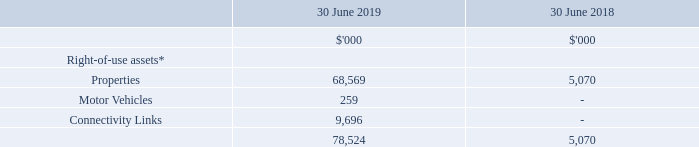12 Leases
(a) Leases
(i) Amounts recognised in the Consolidated Balance Sheet
The Consolidated Balance Sheet includes the following amounts relating to leases:
Additions to the right-of-use assets during the 2019 financial year were $0.3 million.
(ii) Amounts recognised in the Consolidated Statement of Comprehensive Income
The Consolidated Statement of Comprehensive Income shows the following amounts relating to leases:
The total cash outflow for leases in 2019 was $8.6 million.
(iii) The group’s leasing activities and how these are accounted for
The Group has a number of leases over property, motor vehicles, and connectivity links that have varying terms, escalation clauses and renewal rights.
Leases are recognised as a right-of-use asset and a corresponding liability at the date at which the leased asset is available for use by the Group. Each lease payment is allocated between the liability and finance cost. The finance cost is charged to profit or loss over the lease term so as to produce a constant periodic rate of interest on the remaining balance of the liability for each year. The right-of-use asset is depreciated over the shorter of the asset's useful life and the lease term on a straight-line basis.
Assets and liabilities arising from a lease are initially measured on a present value basis. Lease liabilities include the net present value of the following lease payments:
- fixed payments (including in-substance fixed payments), less any lease incentives receivable  fixed payments (including in-substance fixed payments), less any lease incentives receivable
- variable lease payments that are based on an index or a rate
- amounts expected to be payable by the lessee under residual value guarantees
- the exercise price of a purchase option if the lessee is reasonably certain to exercise that option, and
- payments of penalties for terminating the lease, if the lease term reflects the lessee exercising that option.
The lease payments are discounted using the interest rate implicit in the lease, if that rate can be determined, or the Group’s incremental borrowing rate.
Right-of-use assets are measured at cost comprising the following:
- the amount of the initial measurement of lease liability
- any lease payments made at or before the commencement date, less any lease incentives received
- any initial direct costs, and
- restoration costs.
Payments associated with short-term leases and leases of low-value assets are recognised on a straight-line basis as an expense in profit or loss. Short-term leases are leases with a lease term of 12 months or less. Low-value assets comprise IT-equipment and small items of office furniture.
(iv) Extension and termination options
Extension and termination options are included in a number of property and equipment leases across the Group. These terms are used to maximise operational flexibility in terms of managing contracts. The majority of extension and termination options held are exercisable only by the Group and not by the respective lessor.
What costs are taken into account for measuring Right-of-use assets? The amount of the initial measurement of lease liability, any lease payments made at or before the commencement date, less any lease incentives received, any initial direct costs, restoration costs. How much was the additions to the right-of-use assets during FY19? $0.3 million. How much value of right-of-use assets in relation to leases are recognised by the Group?
Answer scale should be: thousand. 78,524. Which year has the higher total right-of-use assets? 78,524> 5,070
Answer: 2019. What was the percentage change in values of properties between 2018 and 2019?
Answer scale should be: percent. (68,569 - 5,070) / 5,070 
Answer: 1252.45. What was the sum of values of motor vehicles and connectivity links in 2019?
Answer scale should be: thousand. 259 + 9,696 
Answer: 9955. 